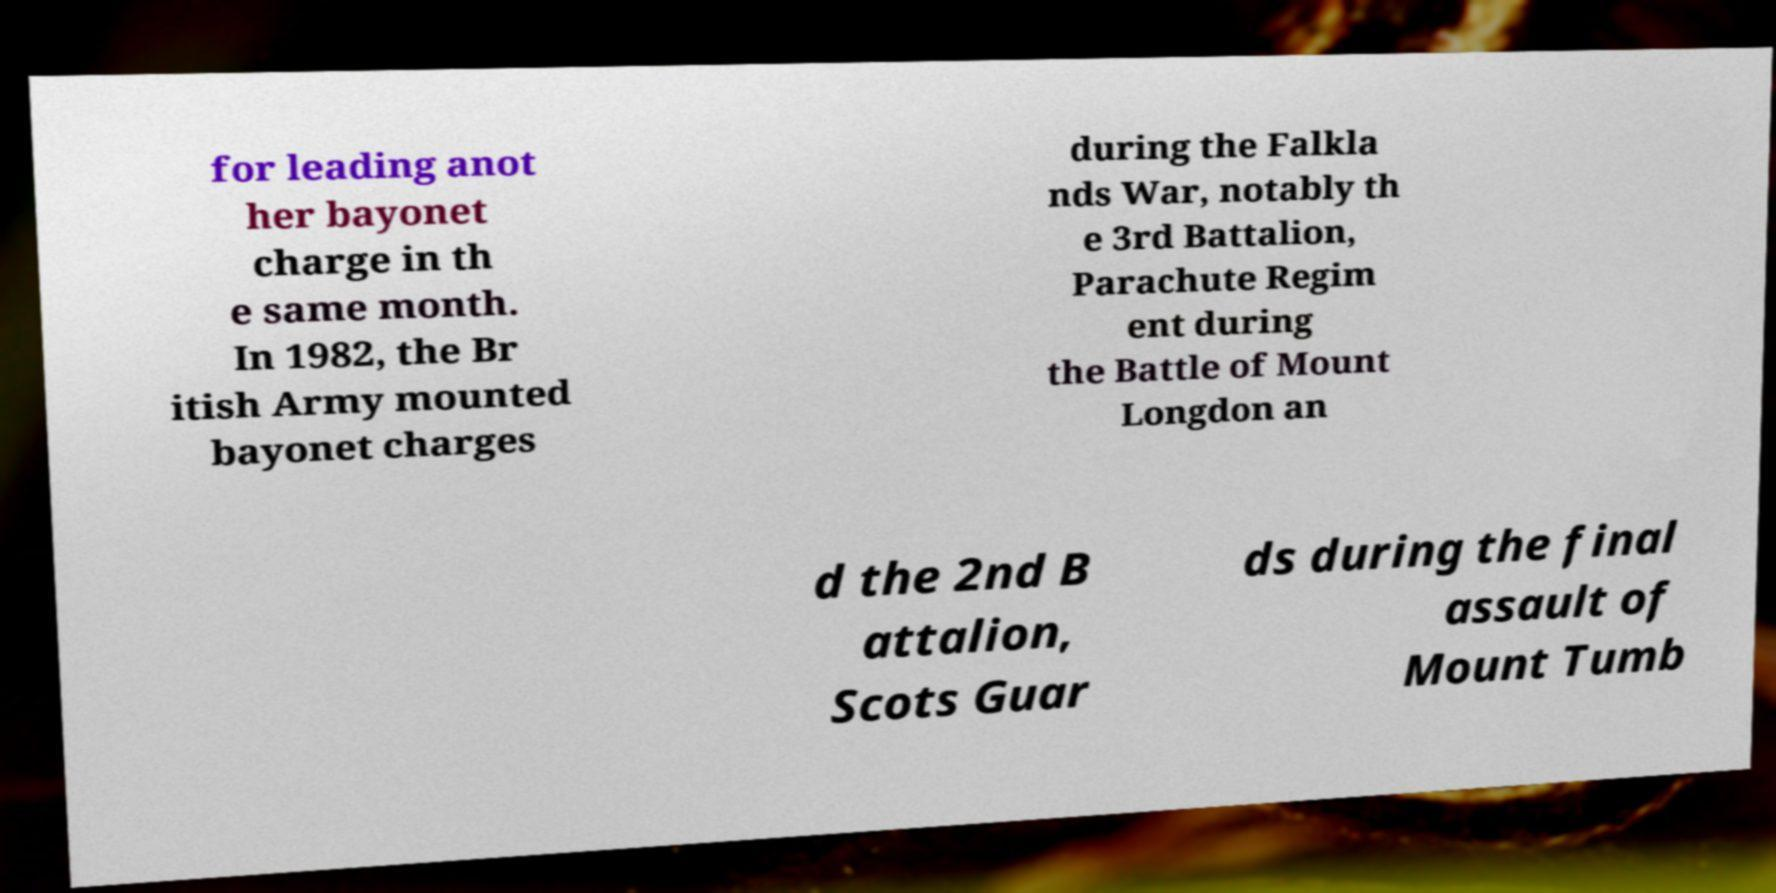Could you extract and type out the text from this image? for leading anot her bayonet charge in th e same month. In 1982, the Br itish Army mounted bayonet charges during the Falkla nds War, notably th e 3rd Battalion, Parachute Regim ent during the Battle of Mount Longdon an d the 2nd B attalion, Scots Guar ds during the final assault of Mount Tumb 